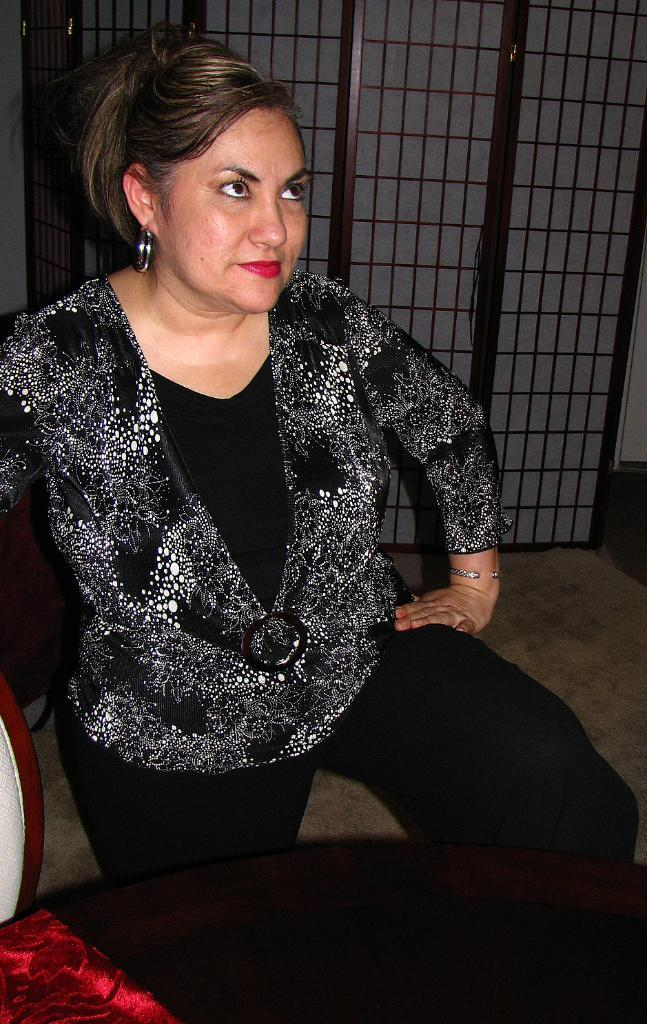What is the main subject of the image? The main subject of the image is a woman. Can you describe the background of the image? There is a gate to a wall in the background of the image. What type of education is the woman pursuing in the image? There is no indication in the image that the woman is pursuing any type of education. What type of yam is the woman holding in the image? There is no yam present in the image. Is the woman playing basketball in the image? There is no basketball or any indication of basketball playing in the image. 